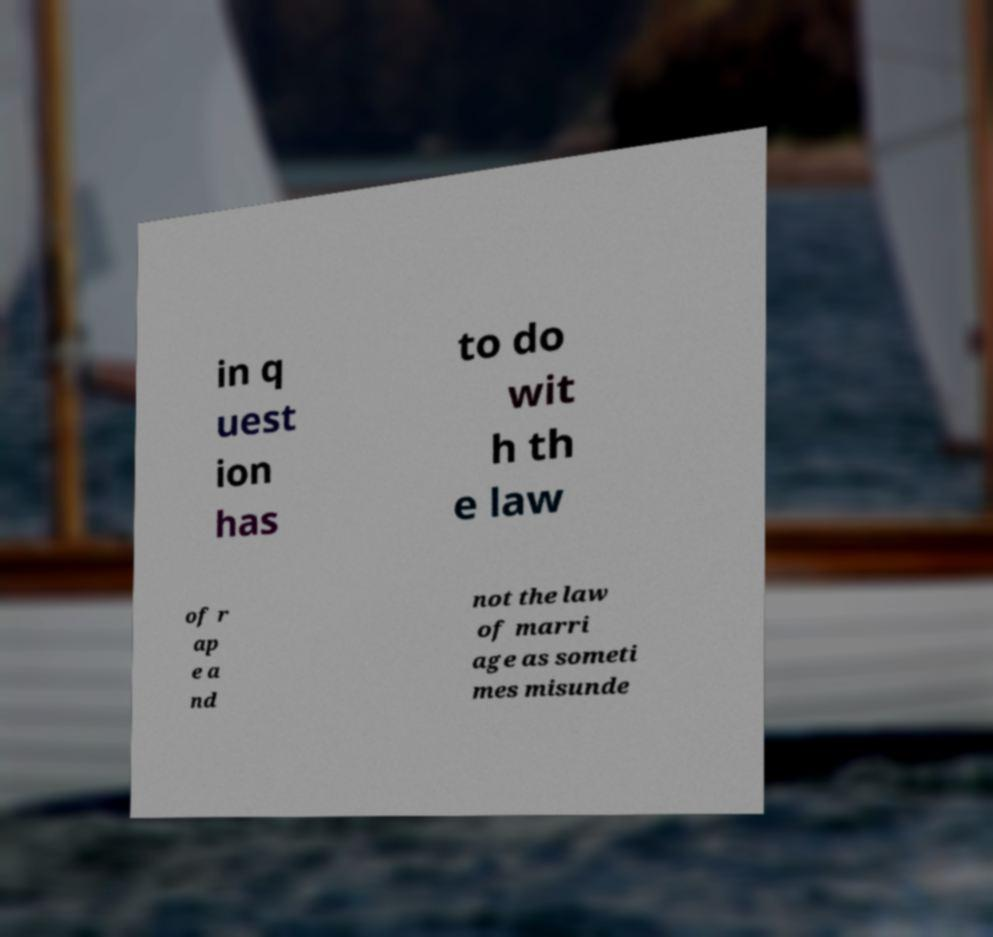For documentation purposes, I need the text within this image transcribed. Could you provide that? in q uest ion has to do wit h th e law of r ap e a nd not the law of marri age as someti mes misunde 